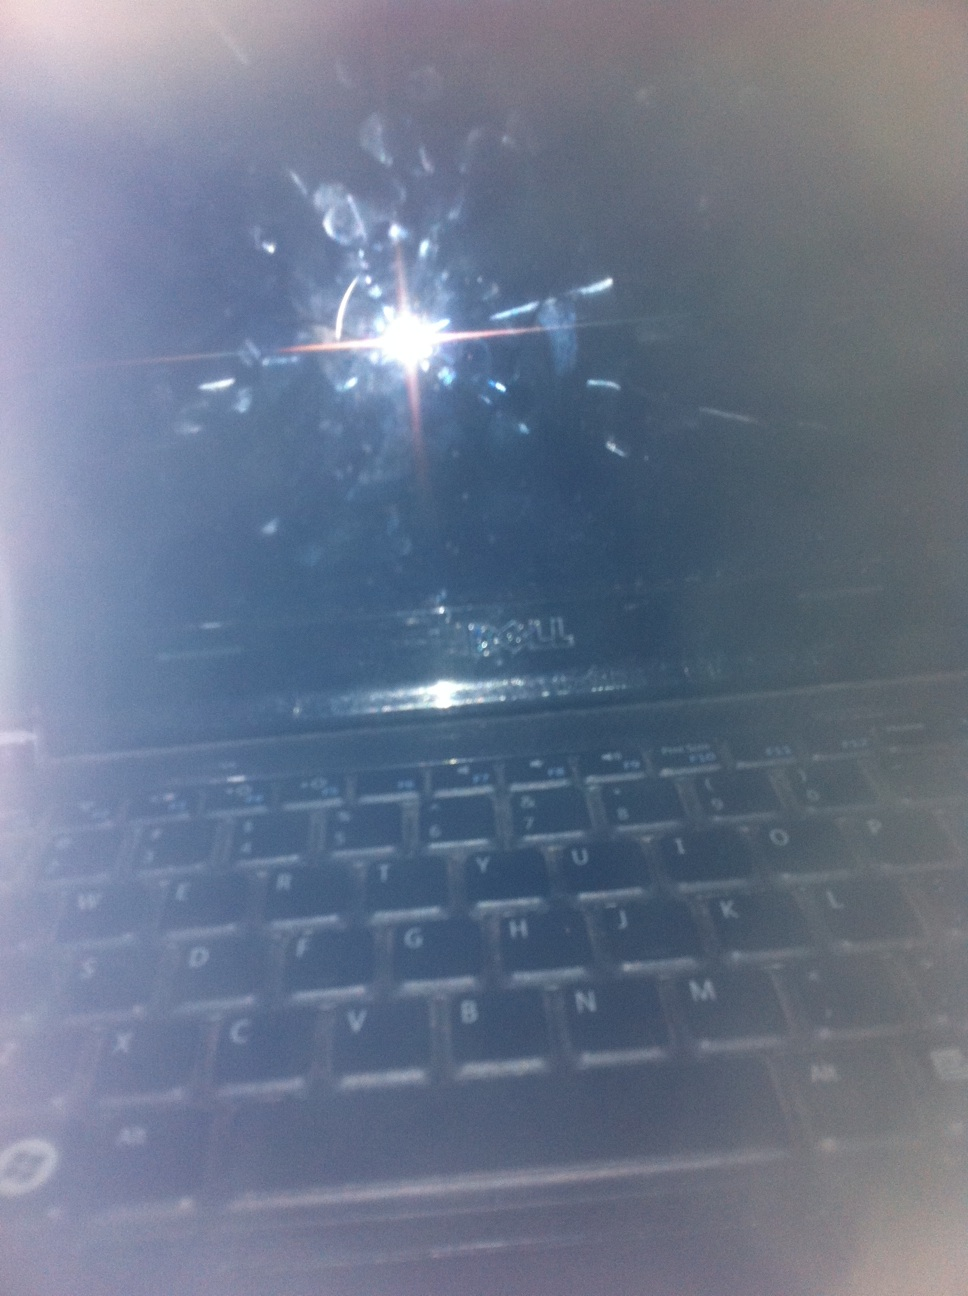What is seen on the laptop screen? There appears to be nothing visible on the laptop screen other than some smudges and reflections from a light source. It looks like the screen is off or displaying a very dark image. 